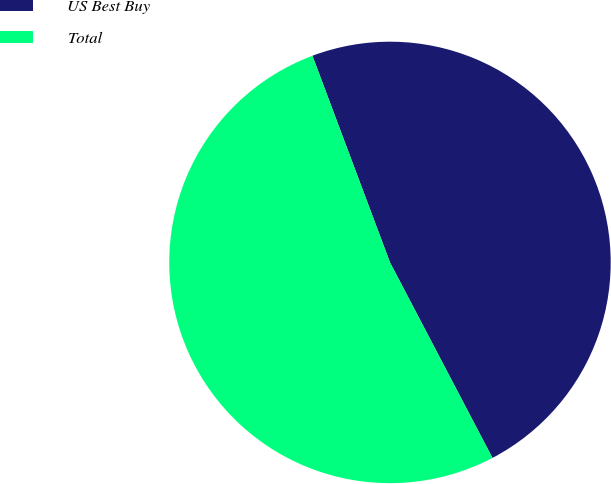Convert chart. <chart><loc_0><loc_0><loc_500><loc_500><pie_chart><fcel>US Best Buy<fcel>Total<nl><fcel>48.03%<fcel>51.97%<nl></chart> 